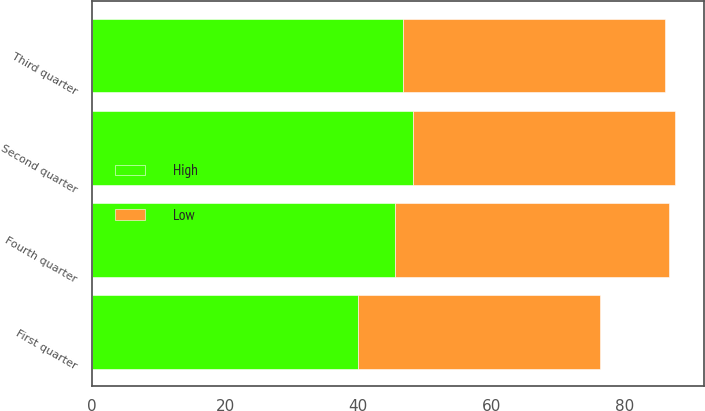Convert chart. <chart><loc_0><loc_0><loc_500><loc_500><stacked_bar_chart><ecel><fcel>First quarter<fcel>Second quarter<fcel>Third quarter<fcel>Fourth quarter<nl><fcel>High<fcel>39.99<fcel>48.22<fcel>46.73<fcel>45.55<nl><fcel>Low<fcel>36.26<fcel>39.23<fcel>39.31<fcel>41.11<nl></chart> 